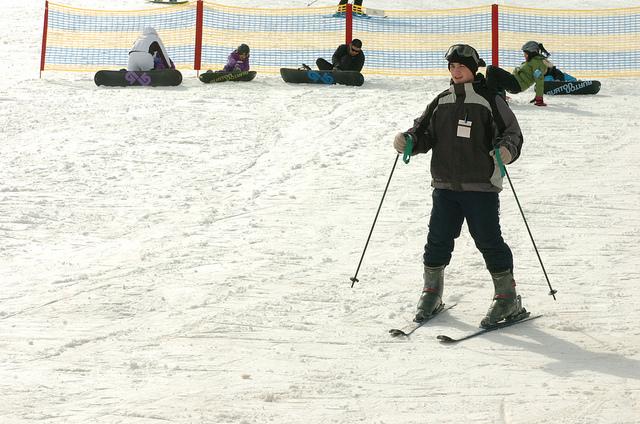What covers the ground?
Be succinct. Snow. How many people are seated?
Write a very short answer. 4. Why is there are fence in the back?
Write a very short answer. Protection. 